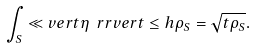Convert formula to latex. <formula><loc_0><loc_0><loc_500><loc_500>\int _ { S } \ll v e r t \eta \ r r v e r t \leq h \rho _ { S } = \sqrt { t \rho _ { S } } .</formula> 